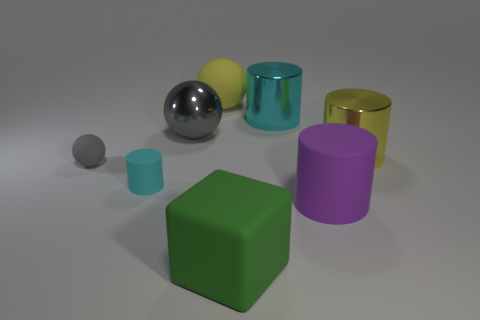There is a gray sphere behind the small gray matte thing; what is it made of?
Your answer should be very brief. Metal. There is a tiny thing that is in front of the small thing left of the cyan matte object that is behind the green rubber block; what shape is it?
Offer a terse response. Cylinder. There is a matte ball that is in front of the yellow shiny cylinder; is its color the same as the cylinder that is in front of the tiny cylinder?
Offer a very short reply. No. Are there fewer large yellow metallic things right of the green matte thing than yellow shiny cylinders to the right of the large rubber ball?
Your response must be concise. No. Is there any other thing that is the same shape as the large purple object?
Give a very brief answer. Yes. There is another matte object that is the same shape as the gray rubber object; what color is it?
Your response must be concise. Yellow. Does the big gray shiny object have the same shape as the large object that is on the right side of the large purple rubber thing?
Make the answer very short. No. How many objects are either yellow objects that are in front of the cyan metal thing or rubber cylinders right of the large green cube?
Offer a very short reply. 2. What is the material of the big green block?
Offer a terse response. Rubber. What number of other things are there of the same size as the gray shiny thing?
Your answer should be very brief. 5. 